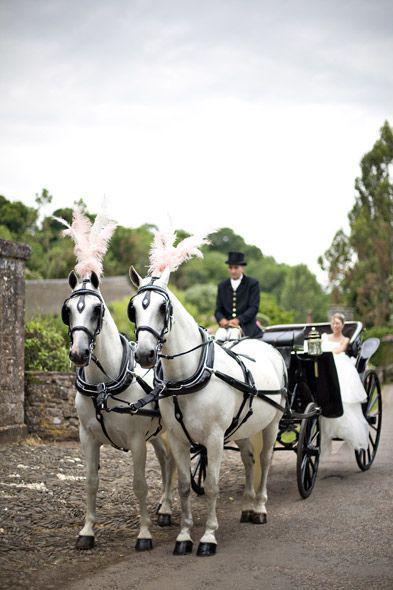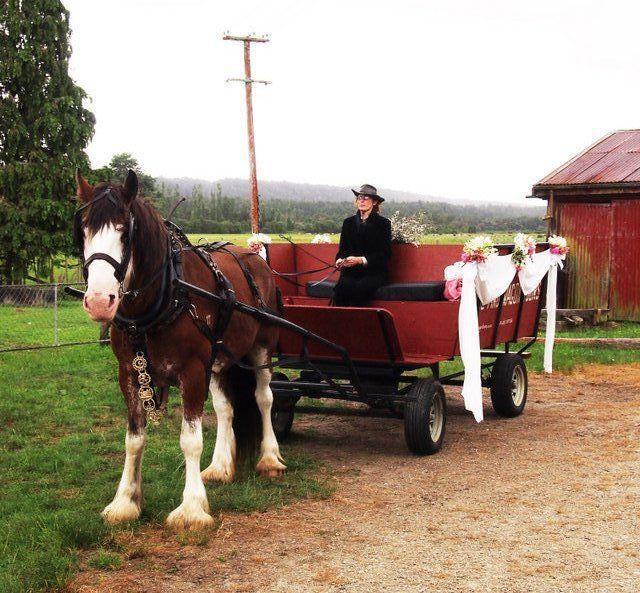The first image is the image on the left, the second image is the image on the right. Assess this claim about the two images: "The wheels on each of the carts are spoked wooden ones .". Correct or not? Answer yes or no. No. The first image is the image on the left, the second image is the image on the right. Given the left and right images, does the statement "An image shows at least one member of a wedding party in the back of a four-wheeled carriage heading away from the camera." hold true? Answer yes or no. No. 